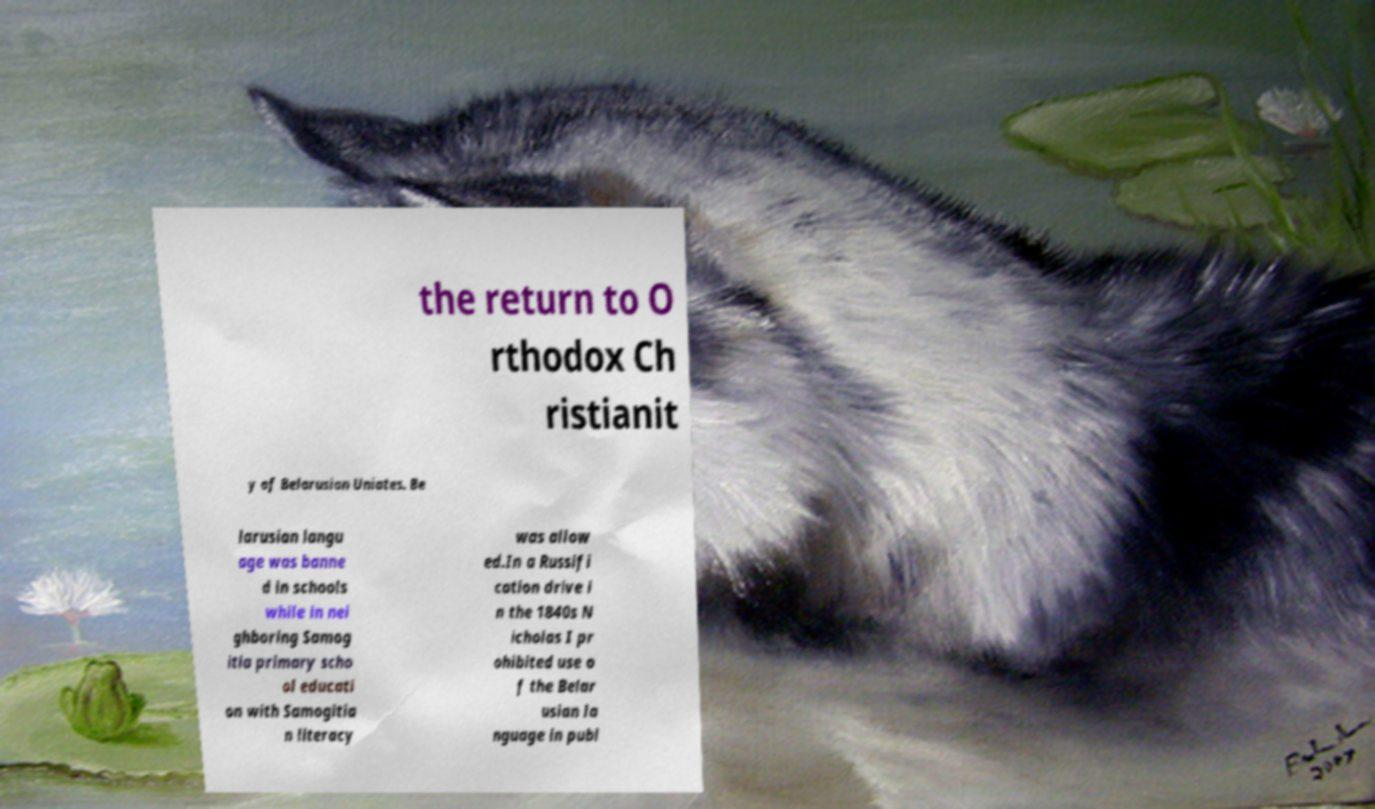What messages or text are displayed in this image? I need them in a readable, typed format. the return to O rthodox Ch ristianit y of Belarusian Uniates. Be larusian langu age was banne d in schools while in nei ghboring Samog itia primary scho ol educati on with Samogitia n literacy was allow ed.In a Russifi cation drive i n the 1840s N icholas I pr ohibited use o f the Belar usian la nguage in publ 